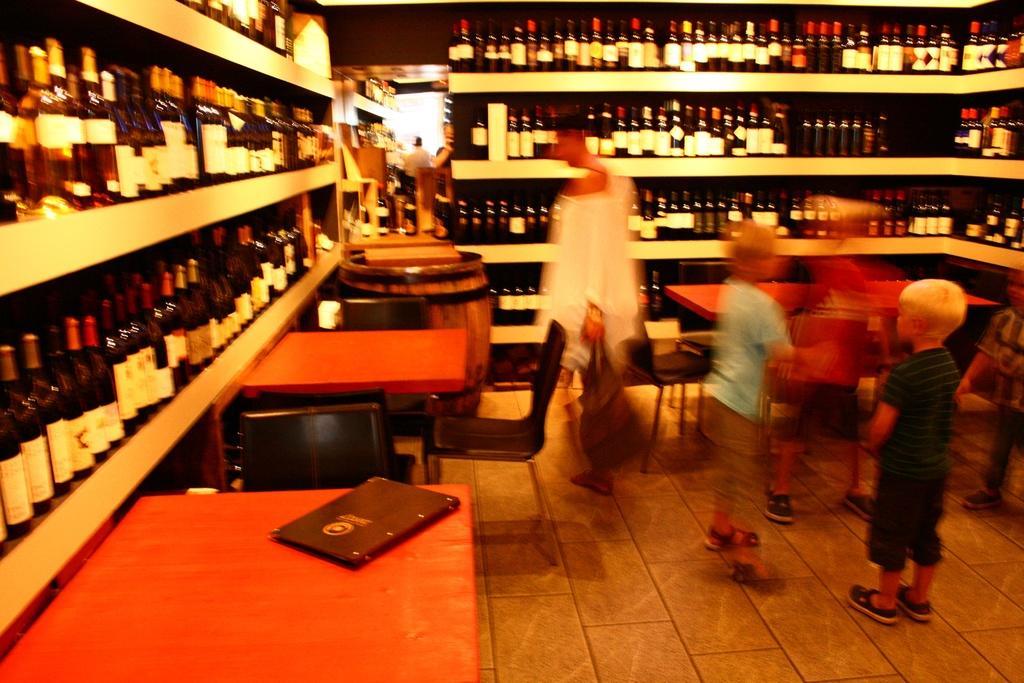Can you describe this image briefly? This is a picture of a wine store. There are many water bottles throughout the store. To the left there are tables, chairs and a menu card and to the right also. In the center of the image there is a person standing, to the right there are fewer kids playing. In the background there is a man standing. 